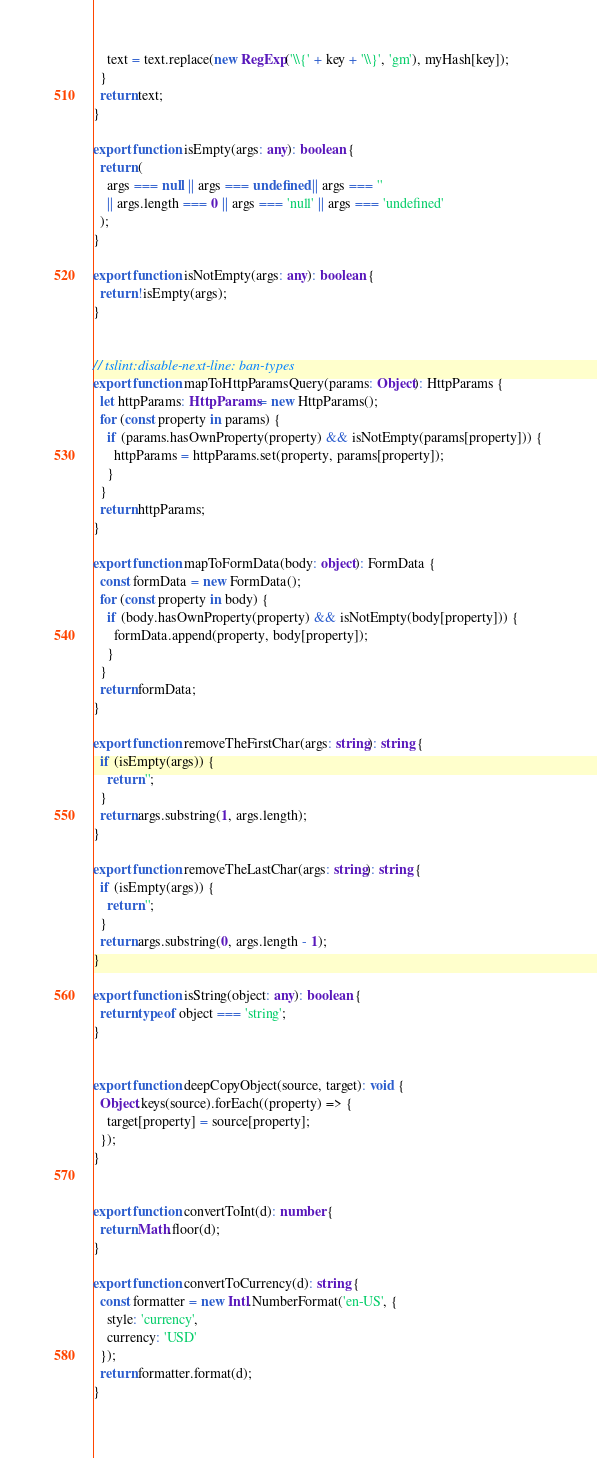Convert code to text. <code><loc_0><loc_0><loc_500><loc_500><_TypeScript_>    text = text.replace(new RegExp('\\{' + key + '\\}', 'gm'), myHash[key]);
  }
  return text;
}

export function isEmpty(args: any): boolean {
  return (
    args === null || args === undefined || args === ''
    || args.length === 0 || args === 'null' || args === 'undefined'
  );
}

export function isNotEmpty(args: any): boolean {
  return !isEmpty(args);
}


// tslint:disable-next-line: ban-types
export function mapToHttpParamsQuery(params: Object): HttpParams {
  let httpParams: HttpParams = new HttpParams();
  for (const property in params) {
    if (params.hasOwnProperty(property) && isNotEmpty(params[property])) {
      httpParams = httpParams.set(property, params[property]);
    }
  }
  return httpParams;
}

export function mapToFormData(body: object): FormData {
  const formData = new FormData();
  for (const property in body) {
    if (body.hasOwnProperty(property) && isNotEmpty(body[property])) {
      formData.append(property, body[property]);
    }
  }
  return formData;
}

export function removeTheFirstChar(args: string): string {
  if (isEmpty(args)) {
    return '';
  }
  return args.substring(1, args.length);
}

export function removeTheLastChar(args: string): string {
  if (isEmpty(args)) {
    return '';
  }
  return args.substring(0, args.length - 1);
}

export function isString(object: any): boolean {
  return typeof object === 'string';
}


export function deepCopyObject(source, target): void {
  Object.keys(source).forEach((property) => {
    target[property] = source[property];
  });
}


export function convertToInt(d): number {
  return Math.floor(d);
}

export function convertToCurrency(d): string {
  const formatter = new Intl.NumberFormat('en-US', {
    style: 'currency',
    currency: 'USD'
  });
  return formatter.format(d);
}
</code> 